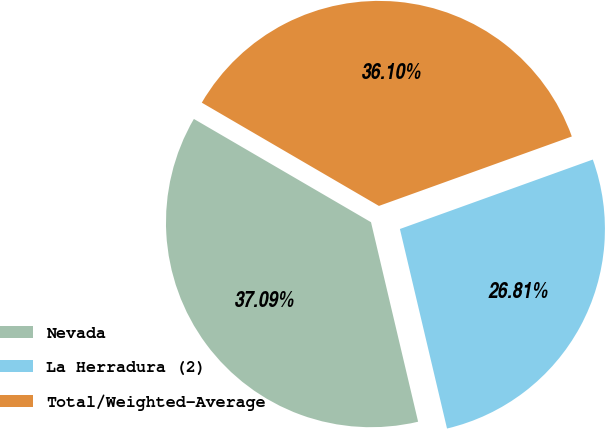Convert chart to OTSL. <chart><loc_0><loc_0><loc_500><loc_500><pie_chart><fcel>Nevada<fcel>La Herradura (2)<fcel>Total/Weighted-Average<nl><fcel>37.09%<fcel>26.81%<fcel>36.1%<nl></chart> 